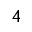Convert formula to latex. <formula><loc_0><loc_0><loc_500><loc_500>^ { 4 }</formula> 